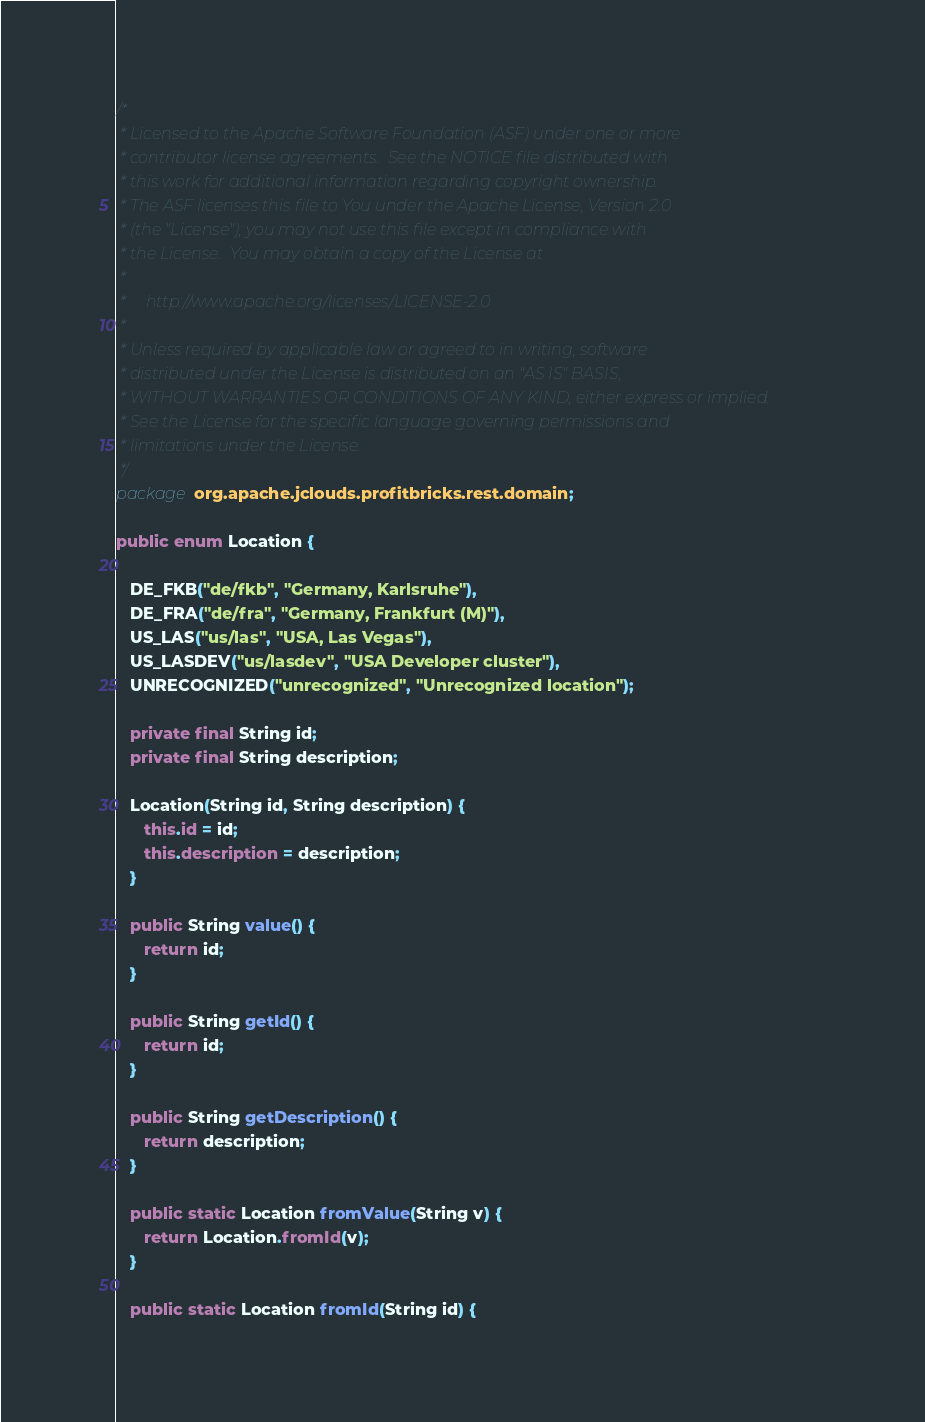<code> <loc_0><loc_0><loc_500><loc_500><_Java_>/*
 * Licensed to the Apache Software Foundation (ASF) under one or more
 * contributor license agreements.  See the NOTICE file distributed with
 * this work for additional information regarding copyright ownership.
 * The ASF licenses this file to You under the Apache License, Version 2.0
 * (the "License"); you may not use this file except in compliance with
 * the License.  You may obtain a copy of the License at
 *
 *     http://www.apache.org/licenses/LICENSE-2.0
 *
 * Unless required by applicable law or agreed to in writing, software
 * distributed under the License is distributed on an "AS IS" BASIS,
 * WITHOUT WARRANTIES OR CONDITIONS OF ANY KIND, either express or implied.
 * See the License for the specific language governing permissions and
 * limitations under the License.
 */
package org.apache.jclouds.profitbricks.rest.domain;

public enum Location {
   
   DE_FKB("de/fkb", "Germany, Karlsruhe"),
   DE_FRA("de/fra", "Germany, Frankfurt (M)"),
   US_LAS("us/las", "USA, Las Vegas"),
   US_LASDEV("us/lasdev", "USA Developer cluster"),
   UNRECOGNIZED("unrecognized", "Unrecognized location");

   private final String id;
   private final String description;

   Location(String id, String description) {
      this.id = id;
      this.description = description;
   }
   
   public String value() {
      return id;
   }

   public String getId() {
      return id;
   }

   public String getDescription() {
      return description;
   }

   public static Location fromValue(String v) {
      return Location.fromId(v);
   }

   public static Location fromId(String id) {</code> 